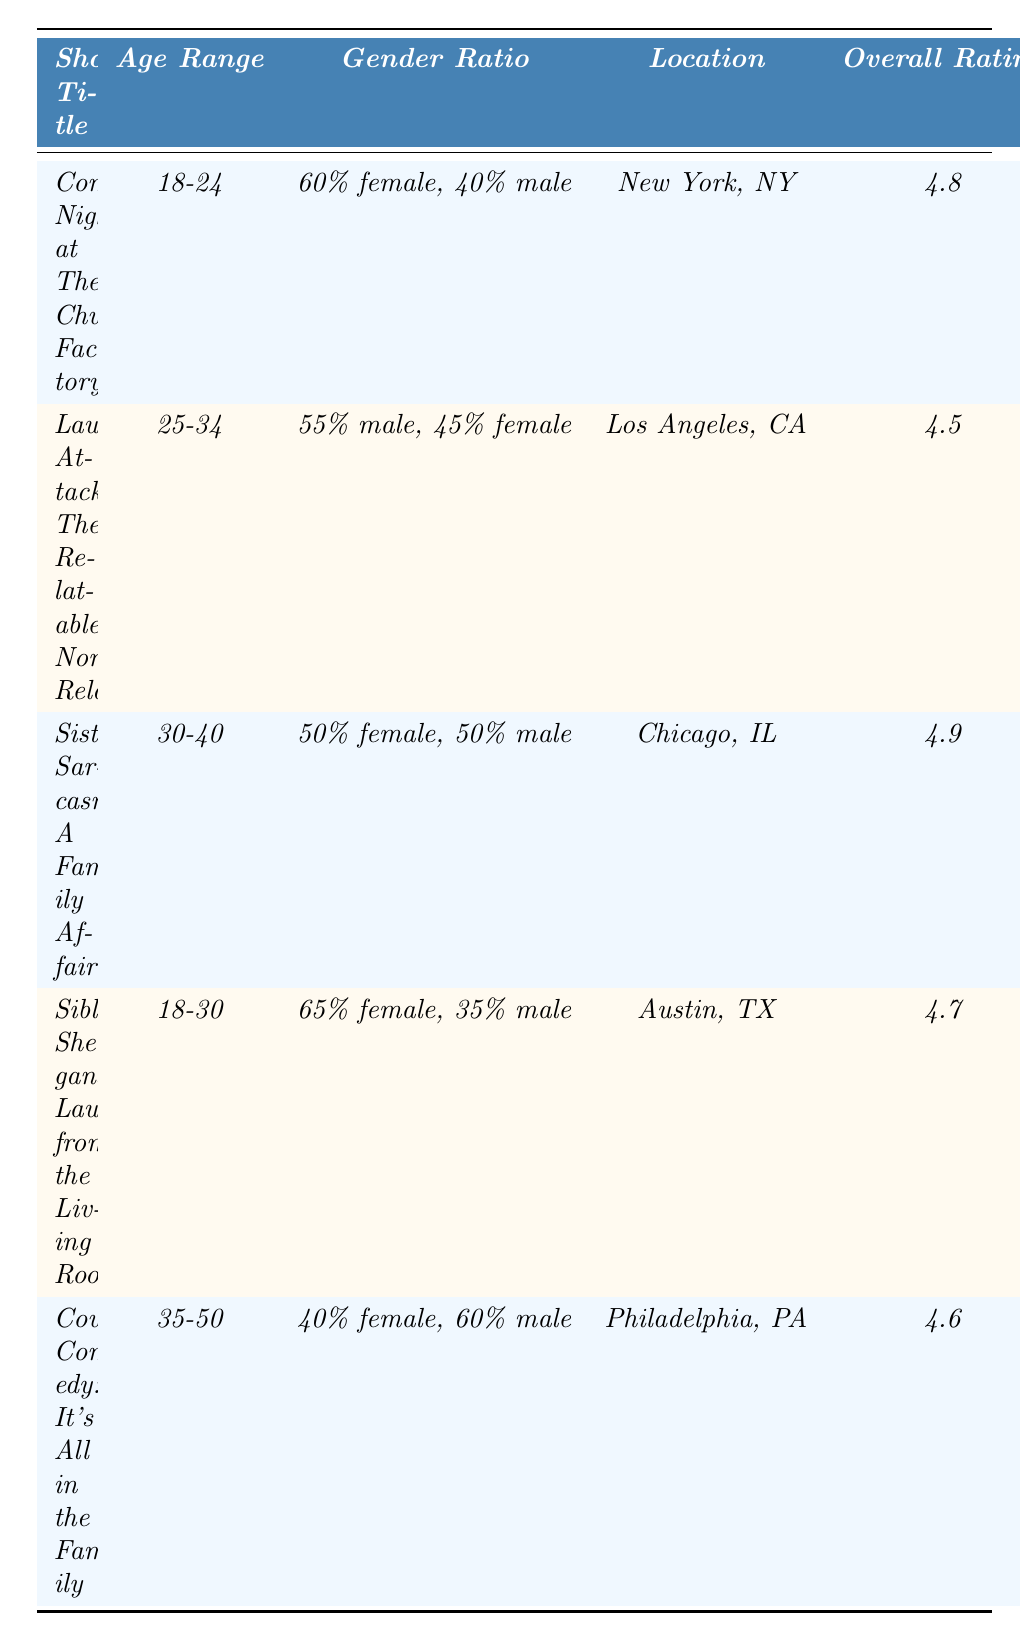What is the overall rating for "Sisterly Sarcasm: A Family Affair"? The overall rating column lists the scores for each show, and for "Sisterly Sarcasm: A Family Affair," the score is 4.9.
Answer: 4.9 What age range does "Laugh Attack: The Relatable Non-Relatable" target? The age range column shows that the target audience for "Laugh Attack: The Relatable Non-Relatable" is 25-34.
Answer: 25-34 Which show has the highest content rating? By comparing the content ratings, "Sisterly Sarcasm: A Family Affair" has a content rating of 5.0, which is the highest among all shows.
Answer: Sisterly Sarcasm: A Family Affair What is the gender ratio for the audience of "Sibling Shenanigans: Laughs from the Living Room"? The gender ratio column specifies that for "Sibling Shenanigans: Laughs from the Living Room," the ratio is 65% female and 35% male.
Answer: 65% female, 35% male Is the overall rating for "Cousin Comedy: It's All in the Family" higher than 4.5? The overall rating for "Cousin Comedy: It's All in the Family" is 4.6, which is higher than 4.5.
Answer: Yes What is the average overall rating of all the shows? The overall ratings are 4.8, 4.5, 4.9, 4.7, and 4.6. Adding these gives 24.5, and dividing by 5 shows the average rating is 24.5/5 = 4.9.
Answer: 4.9 In which location is "Comedy Night at The Chuckle Factory" held? The location column indicates that "Comedy Night at The Chuckle Factory" is held in New York, NY.
Answer: New York, NY What is the difference in overall ratings between the highest and lowest rated shows? The highest overall rating is 4.9 (Sisterly Sarcasm: A Family Affair) and the lowest is 4.5 (Laugh Attack: The Relatable Non-Relatable). The difference is 4.9 - 4.5 = 0.4.
Answer: 0.4 How many shows have an audience demographic primarily consisting of females (above 60%)? By checking the gender ratios, "Comedy Night at The Chuckle Factory" and "Sibling Shenanigans: Laughs from the Living Room" have female percentages over 60%, leading to a total of 2 shows.
Answer: 2 Which show located in Chicago, IL has the best delivery rating? The show located in Chicago, IL is "Sisterly Sarcasm: A Family Affair," with a delivery rating of 4.8, the best delivery rating.
Answer: Sisterly Sarcasm: A Family Affair 